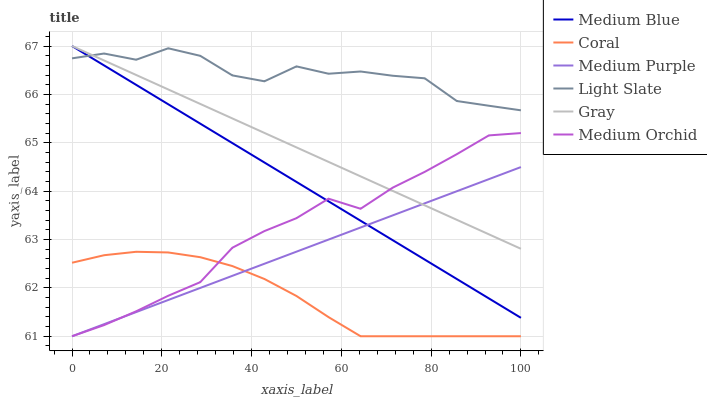Does Coral have the minimum area under the curve?
Answer yes or no. Yes. Does Light Slate have the maximum area under the curve?
Answer yes or no. Yes. Does Light Slate have the minimum area under the curve?
Answer yes or no. No. Does Coral have the maximum area under the curve?
Answer yes or no. No. Is Medium Purple the smoothest?
Answer yes or no. Yes. Is Light Slate the roughest?
Answer yes or no. Yes. Is Coral the smoothest?
Answer yes or no. No. Is Coral the roughest?
Answer yes or no. No. Does Coral have the lowest value?
Answer yes or no. Yes. Does Light Slate have the lowest value?
Answer yes or no. No. Does Medium Blue have the highest value?
Answer yes or no. Yes. Does Light Slate have the highest value?
Answer yes or no. No. Is Coral less than Light Slate?
Answer yes or no. Yes. Is Medium Blue greater than Coral?
Answer yes or no. Yes. Does Medium Blue intersect Light Slate?
Answer yes or no. Yes. Is Medium Blue less than Light Slate?
Answer yes or no. No. Is Medium Blue greater than Light Slate?
Answer yes or no. No. Does Coral intersect Light Slate?
Answer yes or no. No. 